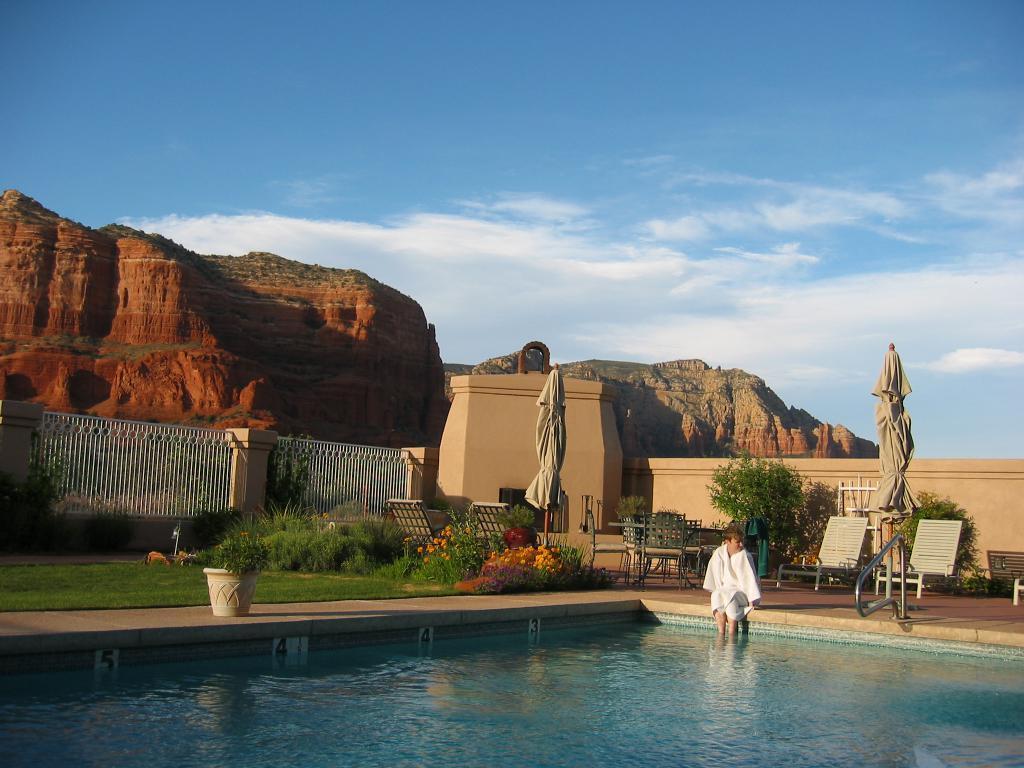How would you summarize this image in a sentence or two? In this picture we can see a person sitting outside a swimming pool with his legs in the water. In the background, we can see many plants, flowers and hills. 